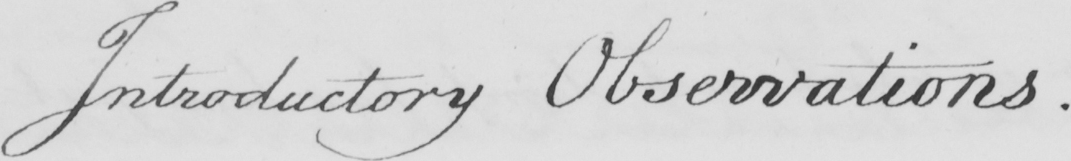What text is written in this handwritten line? Introductory Observations . 